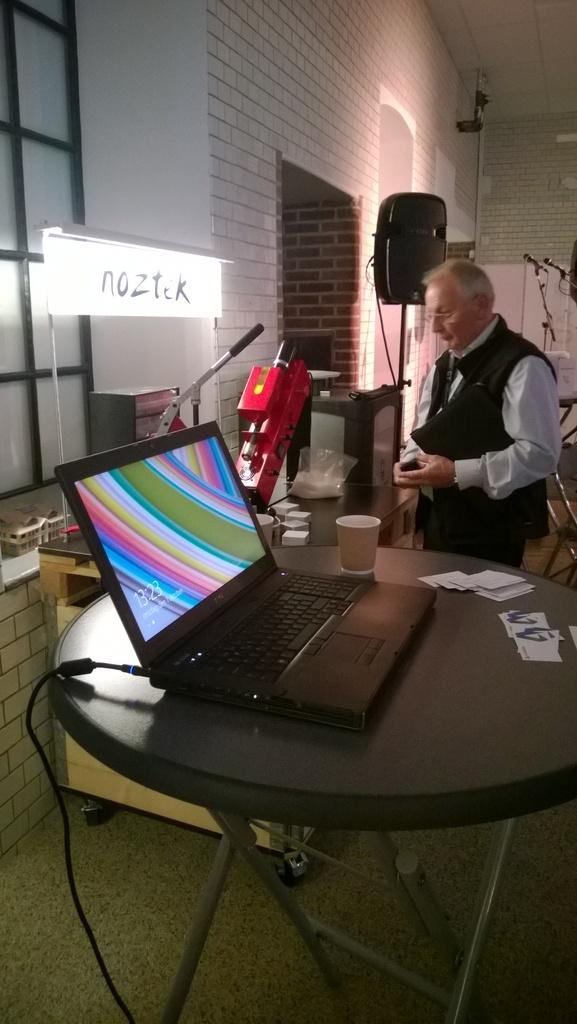What is the main subject in the image? There is a man standing in the image. What objects are on the table in the image? There is a cup and a laptop on the table in the image. What type of clover can be seen growing in the alley behind the man in the image? There is no alley or clover present in the image. 